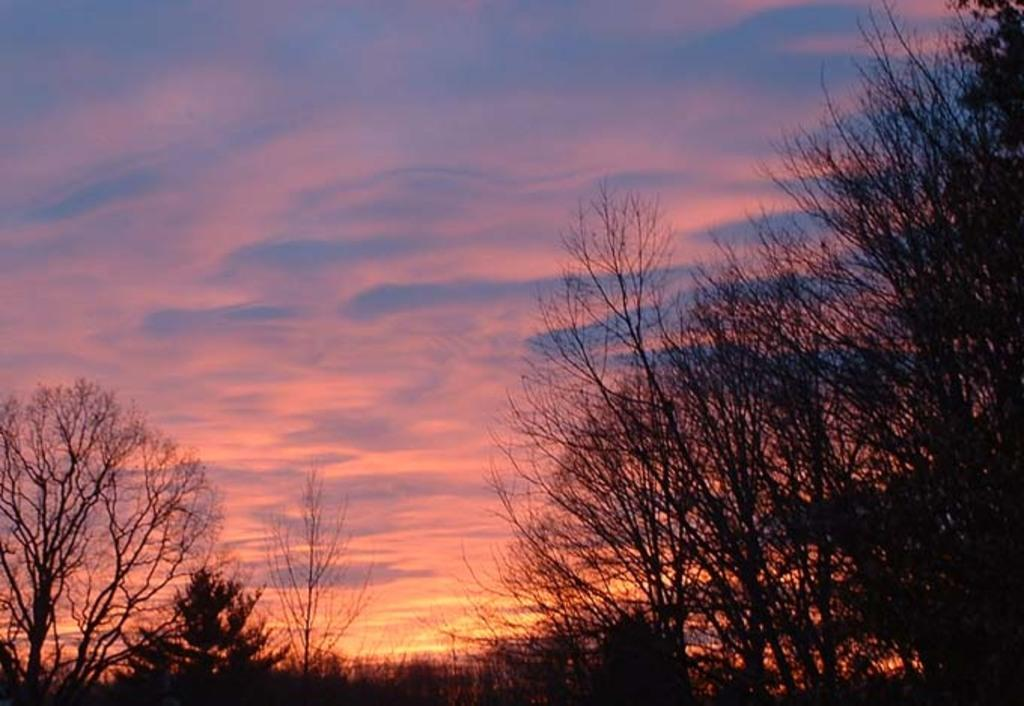What type of scene is depicted in the image? The image depicts a sunset scene. What can be seen in the foreground of the image? There are dry trees in the front of the image. What is visible in the background of the image? The sky is visible in the image. What is the color of the clouds in the sky? Red color clouds are present in the sky. What type of beam is being used to hold up the trees in the image? There is no beam present in the image; the trees are standing on their own. What is the tray being used for in the image? There is no tray present in the image. 